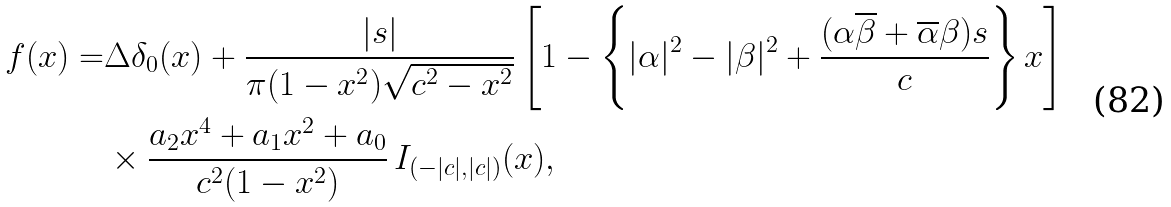<formula> <loc_0><loc_0><loc_500><loc_500>f ( x ) = & \Delta \delta _ { 0 } ( x ) + \frac { | s | } { \pi ( 1 - x ^ { 2 } ) \sqrt { c ^ { 2 } - x ^ { 2 } } } \left [ 1 - \left \{ | \alpha | ^ { 2 } - | \beta | ^ { 2 } + \frac { ( \alpha \overline { \beta } + \overline { \alpha } \beta ) s } { c } \right \} x \right ] \\ & \times \frac { a _ { 2 } x ^ { 4 } + a _ { 1 } x ^ { 2 } + a _ { 0 } } { c ^ { 2 } ( 1 - x ^ { 2 } ) } \, I _ { ( - | c | , | c | ) } ( x ) ,</formula> 